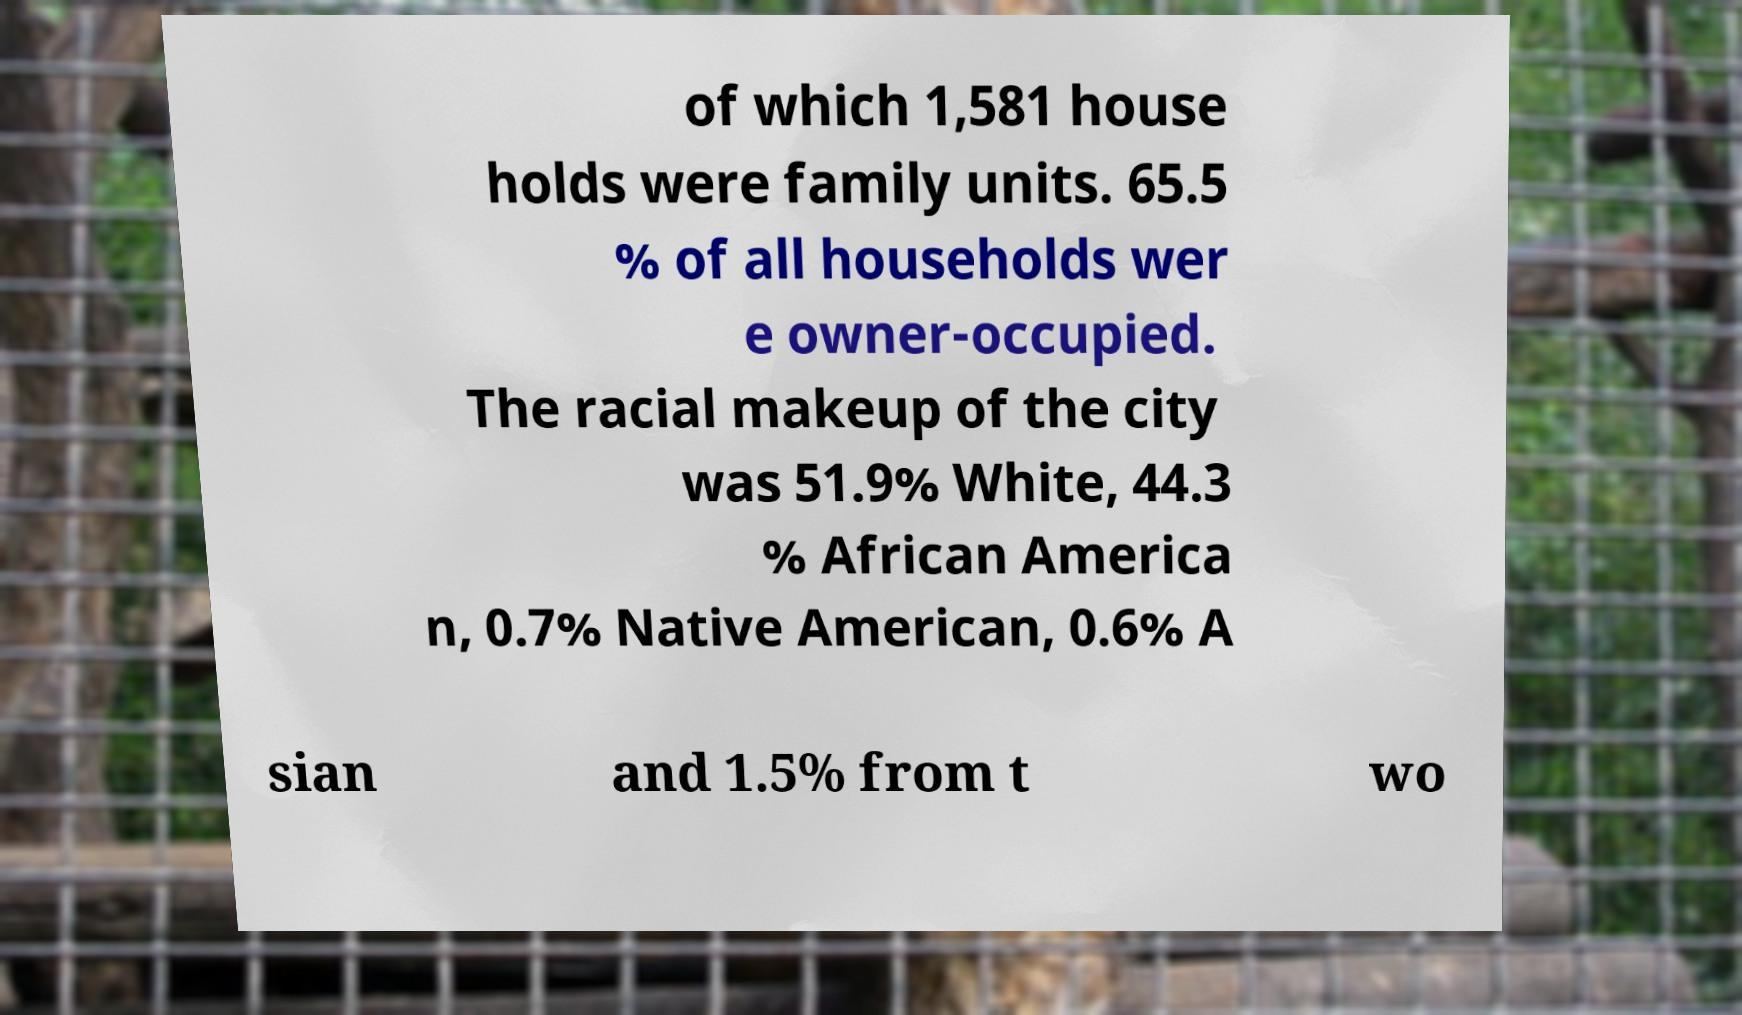Could you assist in decoding the text presented in this image and type it out clearly? of which 1,581 house holds were family units. 65.5 % of all households wer e owner-occupied. The racial makeup of the city was 51.9% White, 44.3 % African America n, 0.7% Native American, 0.6% A sian and 1.5% from t wo 